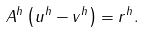Convert formula to latex. <formula><loc_0><loc_0><loc_500><loc_500>A ^ { h } \left ( u ^ { h } - v ^ { h } \right ) = r ^ { h } .</formula> 